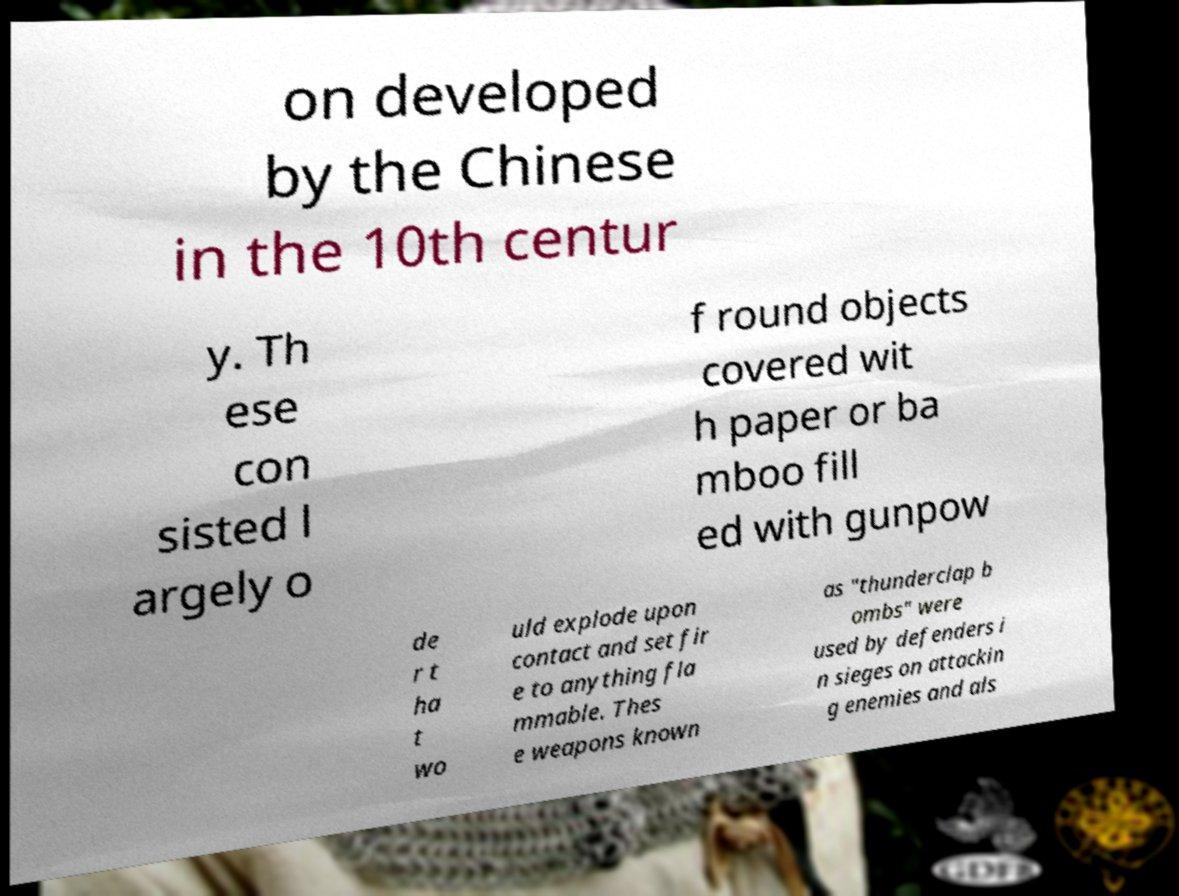Can you accurately transcribe the text from the provided image for me? on developed by the Chinese in the 10th centur y. Th ese con sisted l argely o f round objects covered wit h paper or ba mboo fill ed with gunpow de r t ha t wo uld explode upon contact and set fir e to anything fla mmable. Thes e weapons known as "thunderclap b ombs" were used by defenders i n sieges on attackin g enemies and als 